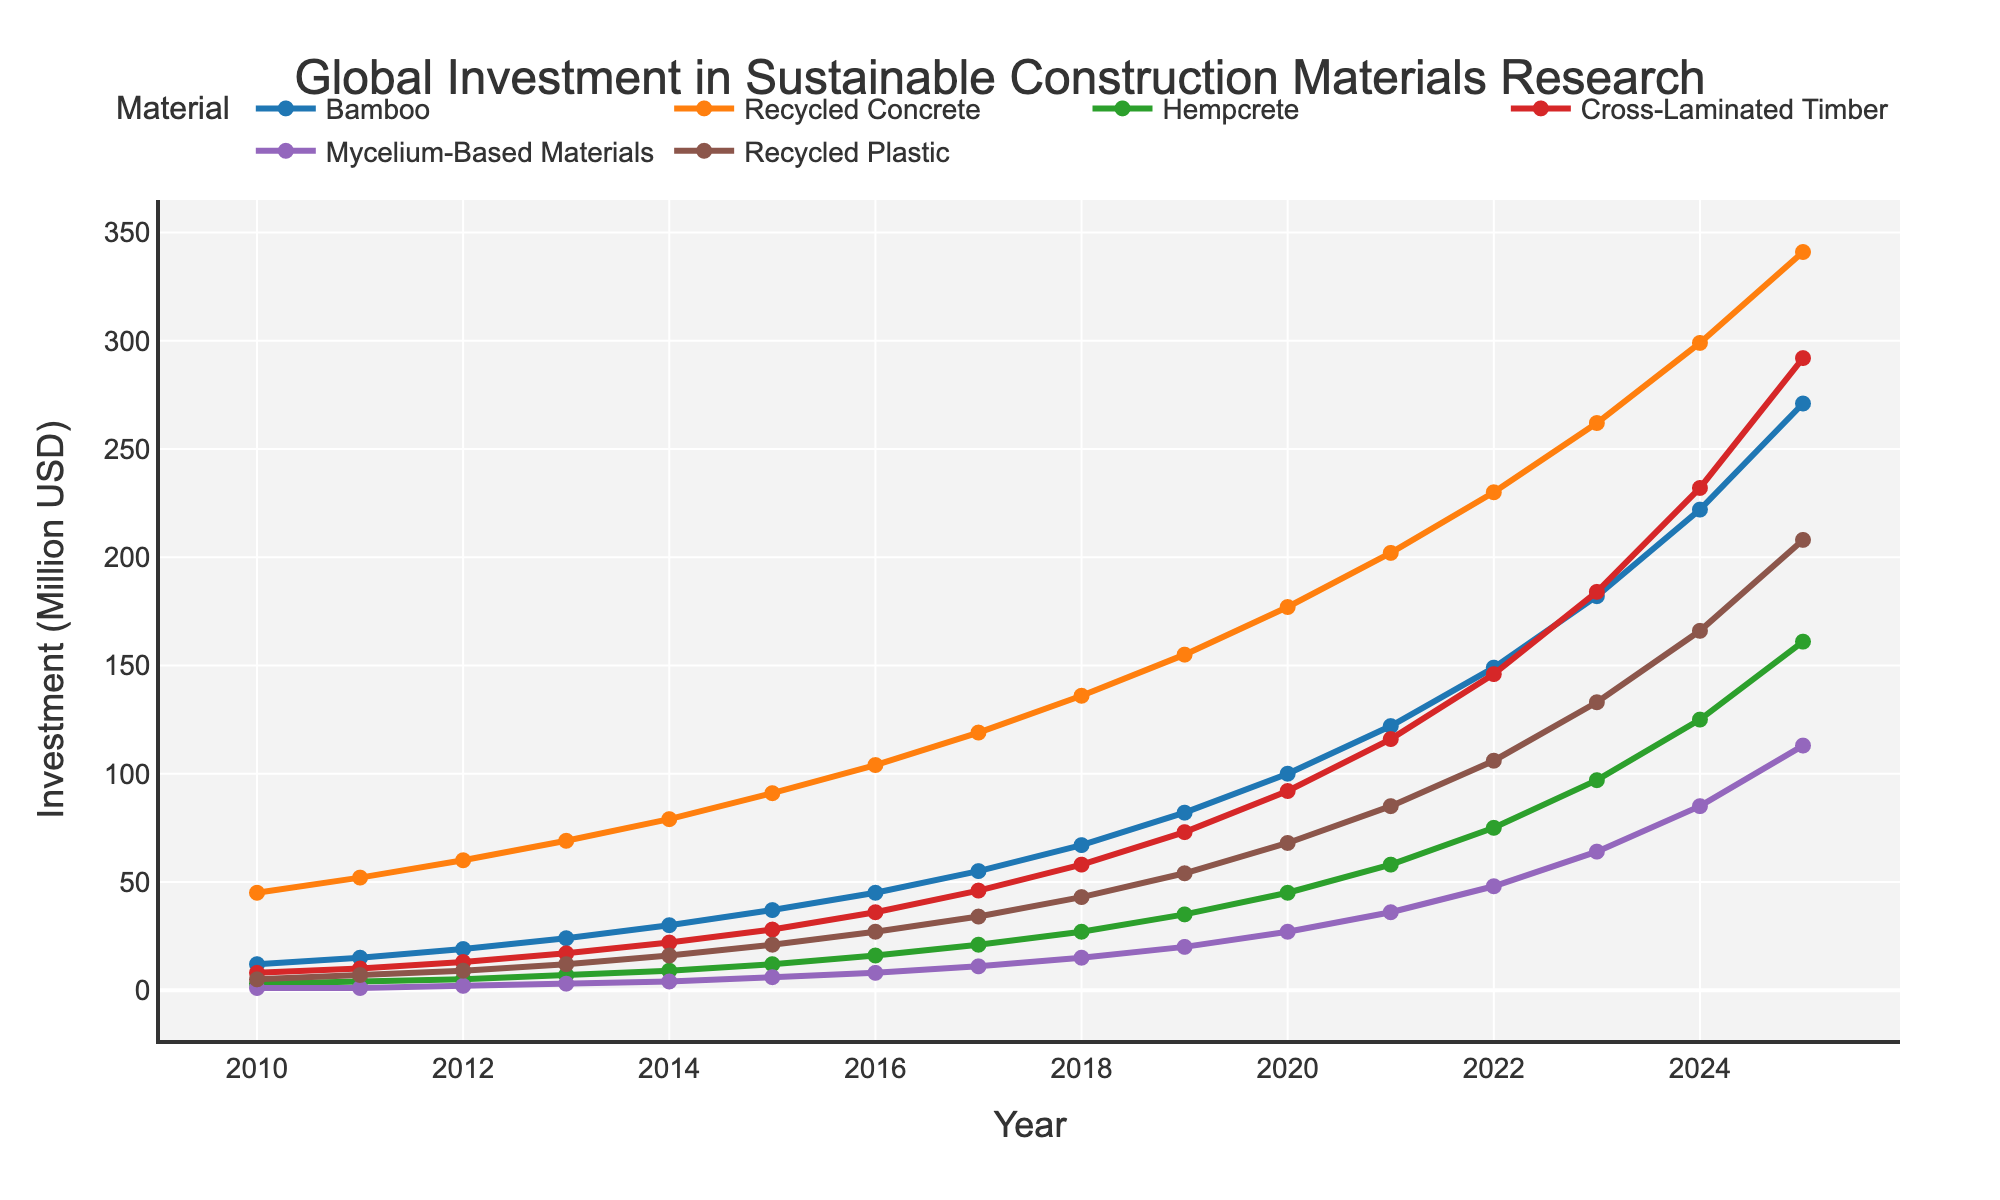What is the projected global investment in Hempcrete in 2025? According to the figure's legend, each line represents a different material. Locate the line for Hempcrete and follow it to the year 2025 on the x-axis, where the y-axis value indicates the investment.
Answer: 161 million USD Compare the investments in Bamboo and Recycled Concrete in 2020. Which one is higher? Find the lines that correspond to Bamboo and Recycled Concrete. For the year 2020, observe the y-axis values for both lines. Compare these values.
Answer: Recycled Concrete How much did the global investment in Mycelium-Based Materials increase from 2016 to 2019? Determine the y-axis values for Mycelium-Based Materials in 2016 and 2019. Subtract the 2016 value from the 2019 value to find the increase in investment.
Answer: 12 million USD Which material shows the steepest increase in investment between 2013 and 2016? Examine the slopes of the lines for each material between 2013 and 2016. The steepest line indicates the quickest rate of increase within this period.
Answer: Bamboo By how much is the projected investment in Recycled Plastic increasing annually from 2023 to 2025? Identify the Recycled Plastic investments for 2023 and 2025 from the y-axis. Subtract the 2023 value from the 2025 value and then divide by 2 (number of years) to find the annual increase.
Answer: 37.5 million USD per year Which material had the least investment in 2010, and what was the amount? Look at the y-axis values for all the materials in the year 2010. The line with the smallest value represents the least investment.
Answer: Mycelium-Based Materials - 1 million USD How does the growth in investment for Cross-Laminated Timber from 2010 to 2020 compare to that for Bamboo over the same period? Calculate the difference in investment values from 2010 to 2020 for both Cross-Laminated Timber and Bamboo. Compare these values to see which one grew more.
Answer: Cross-Laminated Timber had a greater increase What's the average investment in Recycled Concrete for the years 2015 to 2018? Add the y-axis values for Recycled Concrete from 2015 to 2018 and divide by the number of years (4) to get the average value.
Answer: 112.5 million USD Among all materials, which experienced the largest investment increase from 2022 to 2025? Calculate the difference in y-axis values from 2022 to 2025 for all materials. The material with the highest value is the one with the largest increase.
Answer: Bamboo What is the visual trend of the investment in Mycelium-Based Materials from 2010 to 2025? Observe the progression of the line representing Mycelium-Based Materials from 2010 to 2025. Describe the pattern as consistently increasing, leveling off, or any other trend visible.
Answer: Consistently increasing 